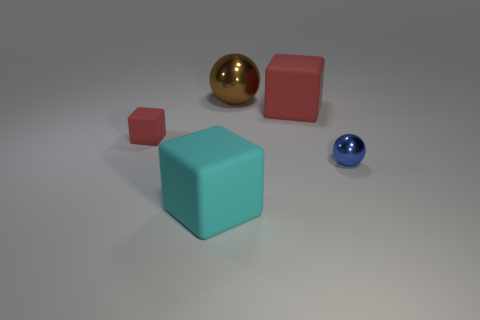How many cylinders are either big metallic objects or small blue metal things?
Your response must be concise. 0. The thing that is to the left of the blue object and in front of the tiny red matte block has what shape?
Keep it short and to the point. Cube. What color is the metal ball that is in front of the ball that is on the left side of the red matte thing that is on the right side of the large cyan object?
Your answer should be very brief. Blue. Is the number of big objects that are in front of the big cyan cube less than the number of yellow shiny cylinders?
Offer a very short reply. No. Does the matte object that is in front of the blue metal sphere have the same shape as the shiny thing behind the blue metallic sphere?
Keep it short and to the point. No. What number of things are either metal spheres on the right side of the large brown metallic object or tiny blue metal objects?
Offer a very short reply. 1. There is a large thing that is the same color as the small rubber cube; what is it made of?
Your answer should be very brief. Rubber. Is there a red rubber object that is left of the big cyan matte thing that is in front of the matte cube that is to the right of the cyan matte thing?
Ensure brevity in your answer.  Yes. Are there fewer large metallic things behind the tiny shiny object than small blue spheres that are behind the big red matte thing?
Offer a terse response. No. The other ball that is the same material as the large brown ball is what color?
Provide a short and direct response. Blue. 